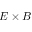Convert formula to latex. <formula><loc_0><loc_0><loc_500><loc_500>E \times B</formula> 